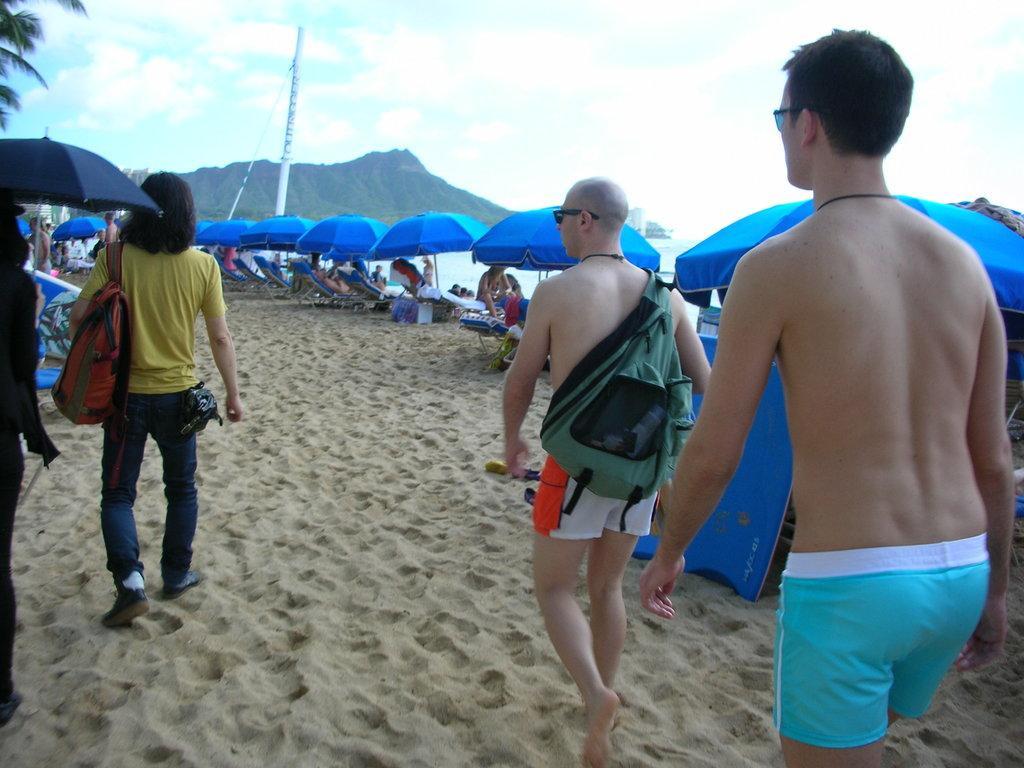In one or two sentences, can you explain what this image depicts? In the image there are few people walking on the sand and around them many people were laying on the chairs under umbrellas, beside them there is a beautiful sea and in the background there are some mountains. 